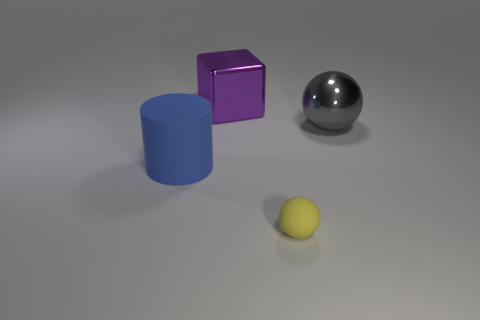Add 3 small green rubber blocks. How many objects exist? 7 Subtract all cylinders. How many objects are left? 3 Subtract 0 blue blocks. How many objects are left? 4 Subtract all brown matte balls. Subtract all gray shiny spheres. How many objects are left? 3 Add 1 yellow rubber objects. How many yellow rubber objects are left? 2 Add 2 gray balls. How many gray balls exist? 3 